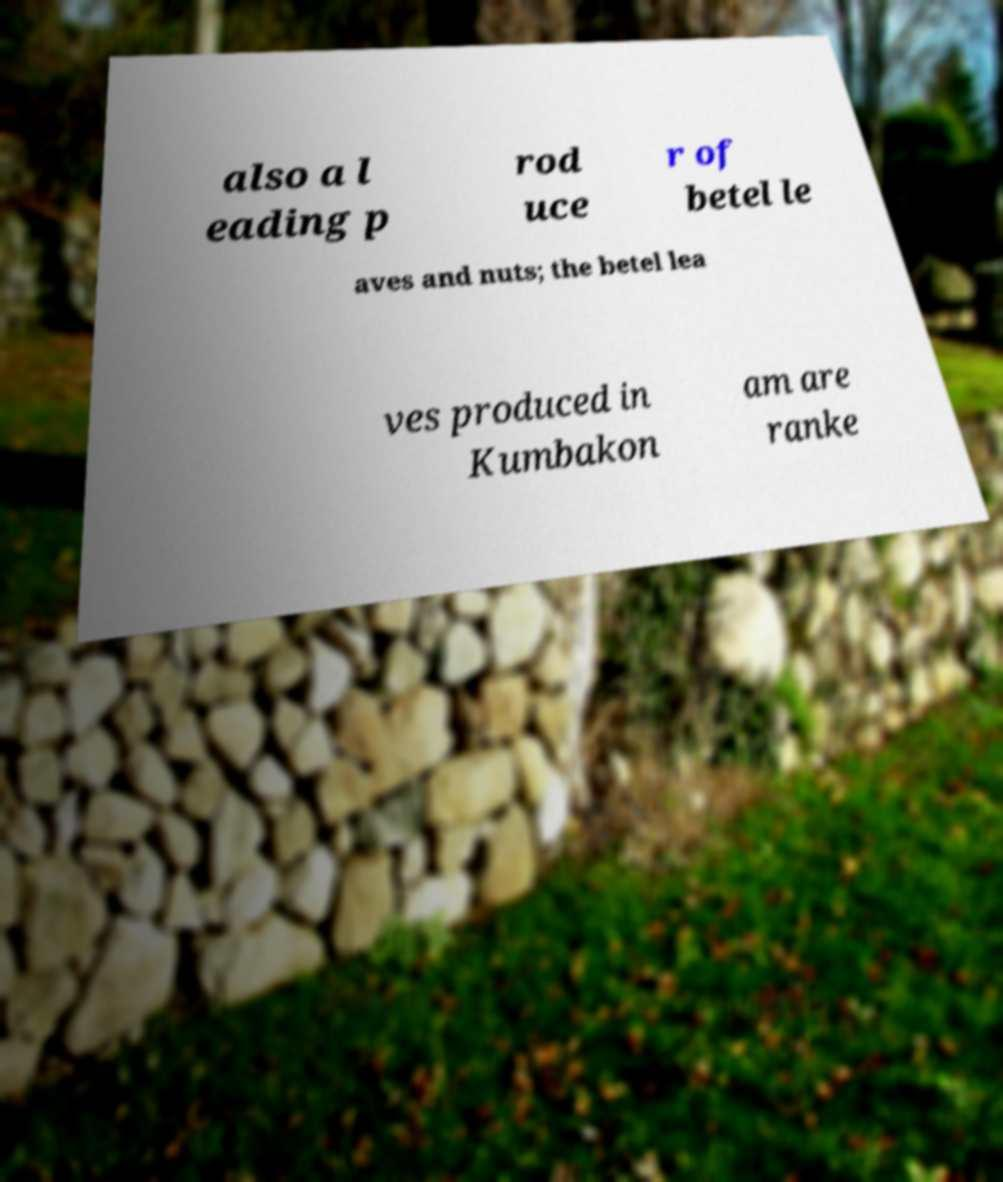Can you accurately transcribe the text from the provided image for me? also a l eading p rod uce r of betel le aves and nuts; the betel lea ves produced in Kumbakon am are ranke 